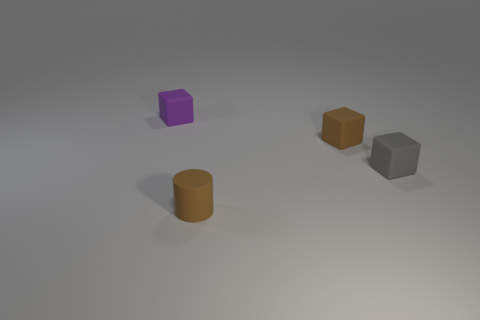How many objects are there in the image, and can you describe their colors and shapes? The image contains four objects. Starting from the left, there is a purple cube, then moving towards the right there are two cylinders—one in front of the other—and they're both colored brown. Lastly, there is a gray cube behind the brown cylinders. 